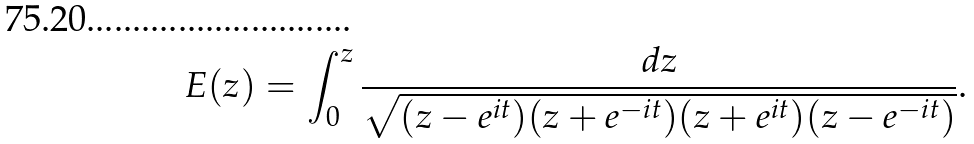Convert formula to latex. <formula><loc_0><loc_0><loc_500><loc_500>E ( z ) = \int _ { 0 } ^ { z } \frac { d z } { \sqrt { ( z - e ^ { i t } ) ( z + e ^ { - i t } ) ( z + e ^ { i t } ) ( z - e ^ { - i t } ) } } .</formula> 